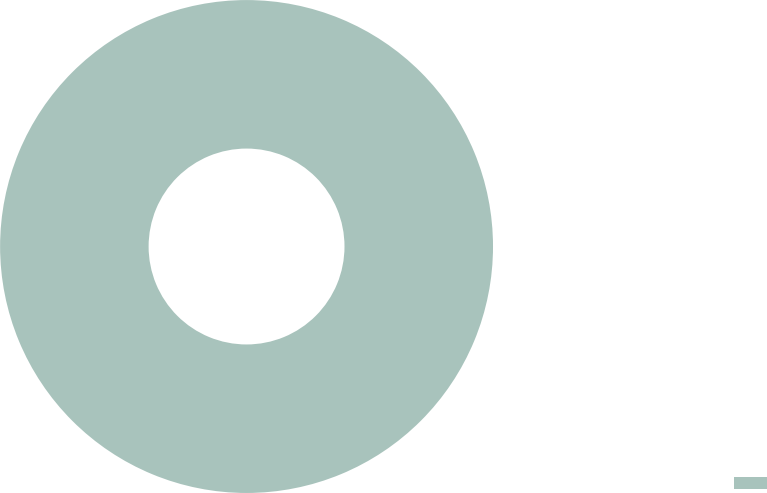Convert chart to OTSL. <chart><loc_0><loc_0><loc_500><loc_500><pie_chart><ecel><nl><fcel>100.0%<nl></chart> 